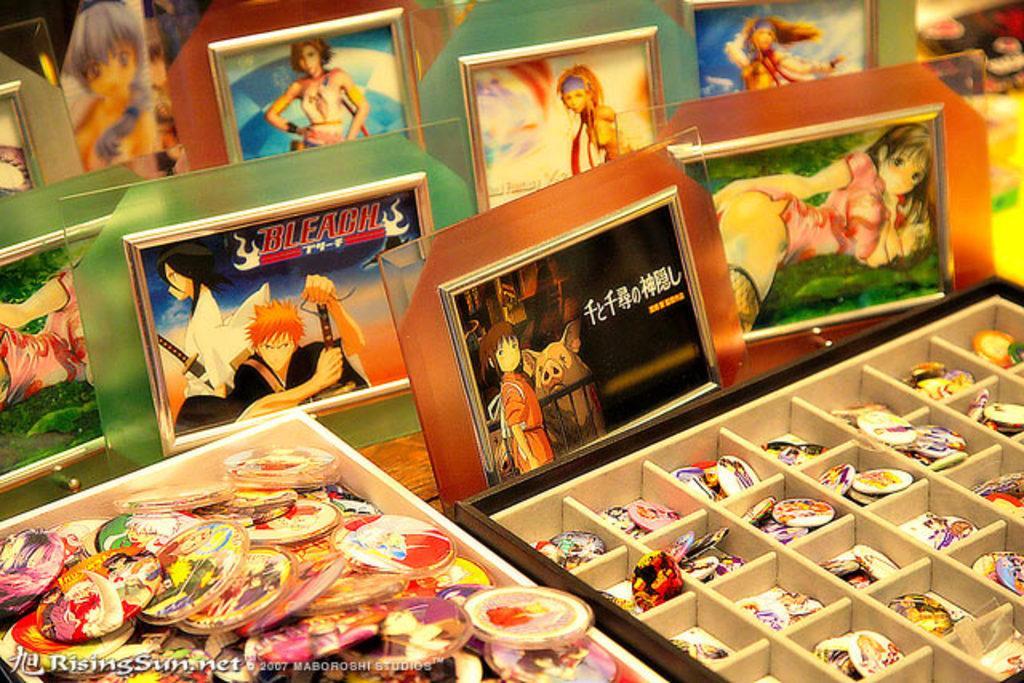Can you describe this image briefly? In this image we can see some photo frames, a bowl of badges and a box placed on the table. 